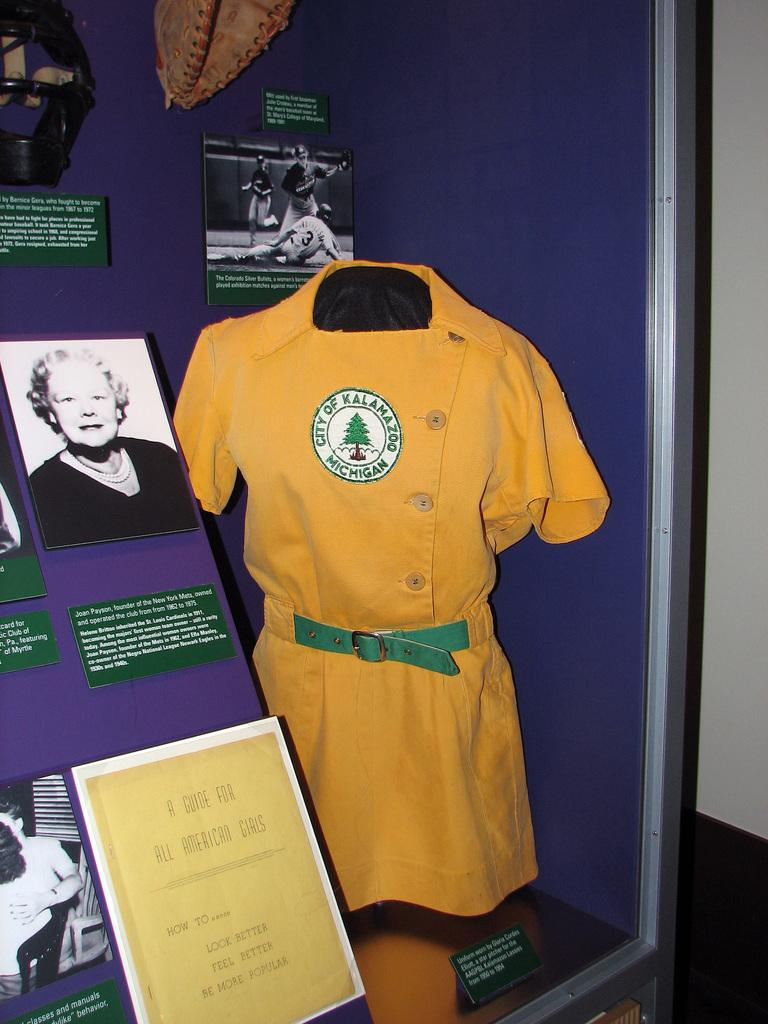What is the main subject of the image? There is a mannequin with a dress in the image. What else can be seen in the image besides the mannequin? There are boards visible in the image. Are there any other objects present in the image? Yes, there are other objects present in the image. What time does the robin arrive in the image? There is no robin present in the image, so it is not possible to determine when it might arrive. 